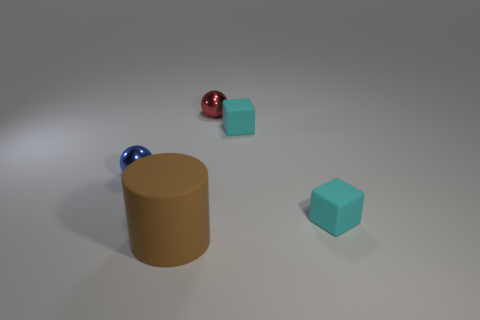Add 4 tiny gray matte things. How many objects exist? 9 Subtract all red balls. How many balls are left? 1 Subtract 0 cyan spheres. How many objects are left? 5 Subtract all cubes. How many objects are left? 3 Subtract 2 balls. How many balls are left? 0 Subtract all purple balls. Subtract all green cylinders. How many balls are left? 2 Subtract all cyan cubes. How many blue balls are left? 1 Subtract all matte blocks. Subtract all tiny red metal objects. How many objects are left? 2 Add 5 metal things. How many metal things are left? 7 Add 2 tiny cyan rubber cubes. How many tiny cyan rubber cubes exist? 4 